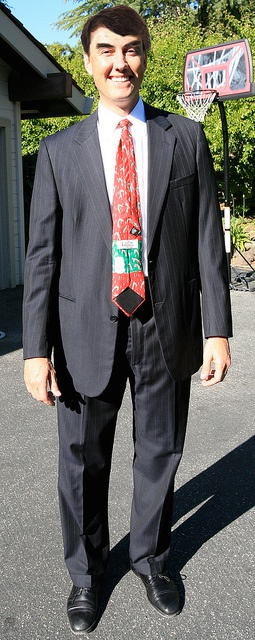Describe the objects in this image and their specific colors. I can see people in gray, black, and white tones and tie in gray, salmon, white, and black tones in this image. 